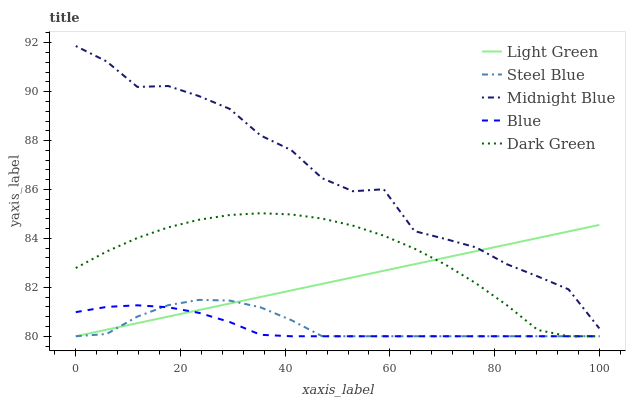Does Blue have the minimum area under the curve?
Answer yes or no. Yes. Does Midnight Blue have the maximum area under the curve?
Answer yes or no. Yes. Does Dark Green have the minimum area under the curve?
Answer yes or no. No. Does Dark Green have the maximum area under the curve?
Answer yes or no. No. Is Light Green the smoothest?
Answer yes or no. Yes. Is Midnight Blue the roughest?
Answer yes or no. Yes. Is Dark Green the smoothest?
Answer yes or no. No. Is Dark Green the roughest?
Answer yes or no. No. Does Blue have the lowest value?
Answer yes or no. Yes. Does Midnight Blue have the lowest value?
Answer yes or no. No. Does Midnight Blue have the highest value?
Answer yes or no. Yes. Does Dark Green have the highest value?
Answer yes or no. No. Is Steel Blue less than Midnight Blue?
Answer yes or no. Yes. Is Midnight Blue greater than Dark Green?
Answer yes or no. Yes. Does Light Green intersect Midnight Blue?
Answer yes or no. Yes. Is Light Green less than Midnight Blue?
Answer yes or no. No. Is Light Green greater than Midnight Blue?
Answer yes or no. No. Does Steel Blue intersect Midnight Blue?
Answer yes or no. No. 